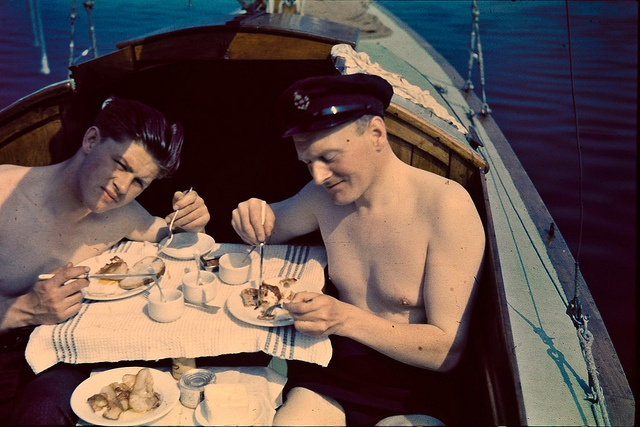Describe the objects in this image and their specific colors. I can see boat in black, navy, gray, and tan tones, people in navy, black, tan, and gray tones, dining table in navy, tan, gray, and darkgray tones, people in navy, gray, black, and tan tones, and bowl in navy, tan, gray, and darkgray tones in this image. 